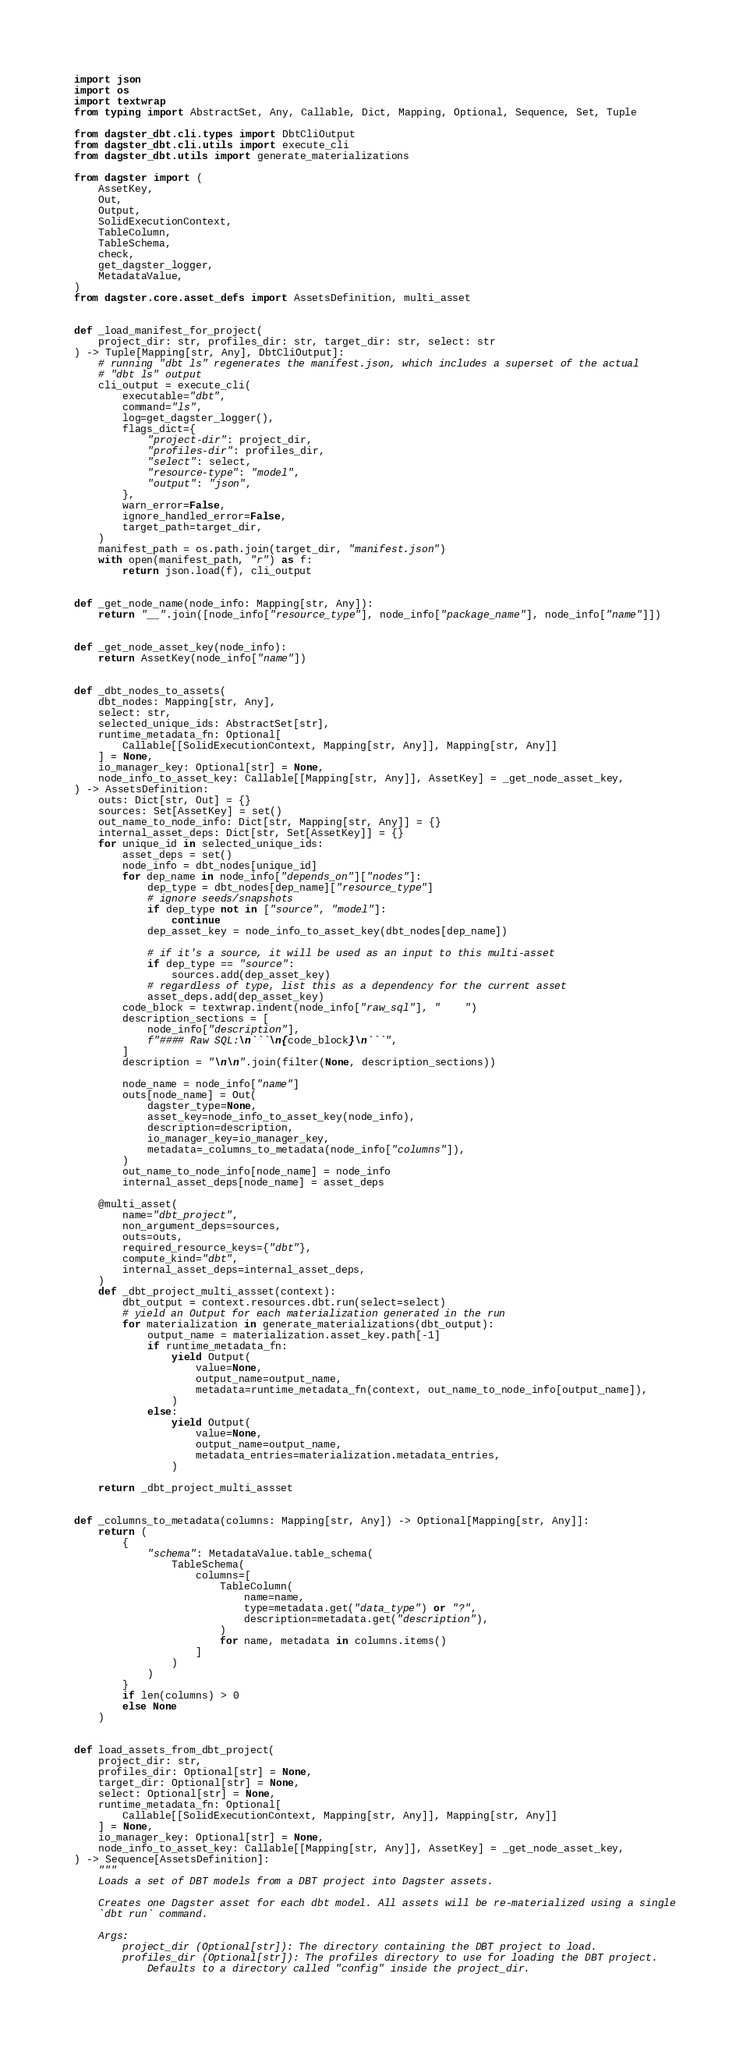Convert code to text. <code><loc_0><loc_0><loc_500><loc_500><_Python_>import json
import os
import textwrap
from typing import AbstractSet, Any, Callable, Dict, Mapping, Optional, Sequence, Set, Tuple

from dagster_dbt.cli.types import DbtCliOutput
from dagster_dbt.cli.utils import execute_cli
from dagster_dbt.utils import generate_materializations

from dagster import (
    AssetKey,
    Out,
    Output,
    SolidExecutionContext,
    TableColumn,
    TableSchema,
    check,
    get_dagster_logger,
    MetadataValue,
)
from dagster.core.asset_defs import AssetsDefinition, multi_asset


def _load_manifest_for_project(
    project_dir: str, profiles_dir: str, target_dir: str, select: str
) -> Tuple[Mapping[str, Any], DbtCliOutput]:
    # running "dbt ls" regenerates the manifest.json, which includes a superset of the actual
    # "dbt ls" output
    cli_output = execute_cli(
        executable="dbt",
        command="ls",
        log=get_dagster_logger(),
        flags_dict={
            "project-dir": project_dir,
            "profiles-dir": profiles_dir,
            "select": select,
            "resource-type": "model",
            "output": "json",
        },
        warn_error=False,
        ignore_handled_error=False,
        target_path=target_dir,
    )
    manifest_path = os.path.join(target_dir, "manifest.json")
    with open(manifest_path, "r") as f:
        return json.load(f), cli_output


def _get_node_name(node_info: Mapping[str, Any]):
    return "__".join([node_info["resource_type"], node_info["package_name"], node_info["name"]])


def _get_node_asset_key(node_info):
    return AssetKey(node_info["name"])


def _dbt_nodes_to_assets(
    dbt_nodes: Mapping[str, Any],
    select: str,
    selected_unique_ids: AbstractSet[str],
    runtime_metadata_fn: Optional[
        Callable[[SolidExecutionContext, Mapping[str, Any]], Mapping[str, Any]]
    ] = None,
    io_manager_key: Optional[str] = None,
    node_info_to_asset_key: Callable[[Mapping[str, Any]], AssetKey] = _get_node_asset_key,
) -> AssetsDefinition:
    outs: Dict[str, Out] = {}
    sources: Set[AssetKey] = set()
    out_name_to_node_info: Dict[str, Mapping[str, Any]] = {}
    internal_asset_deps: Dict[str, Set[AssetKey]] = {}
    for unique_id in selected_unique_ids:
        asset_deps = set()
        node_info = dbt_nodes[unique_id]
        for dep_name in node_info["depends_on"]["nodes"]:
            dep_type = dbt_nodes[dep_name]["resource_type"]
            # ignore seeds/snapshots
            if dep_type not in ["source", "model"]:
                continue
            dep_asset_key = node_info_to_asset_key(dbt_nodes[dep_name])

            # if it's a source, it will be used as an input to this multi-asset
            if dep_type == "source":
                sources.add(dep_asset_key)
            # regardless of type, list this as a dependency for the current asset
            asset_deps.add(dep_asset_key)
        code_block = textwrap.indent(node_info["raw_sql"], "    ")
        description_sections = [
            node_info["description"],
            f"#### Raw SQL:\n```\n{code_block}\n```",
        ]
        description = "\n\n".join(filter(None, description_sections))

        node_name = node_info["name"]
        outs[node_name] = Out(
            dagster_type=None,
            asset_key=node_info_to_asset_key(node_info),
            description=description,
            io_manager_key=io_manager_key,
            metadata=_columns_to_metadata(node_info["columns"]),
        )
        out_name_to_node_info[node_name] = node_info
        internal_asset_deps[node_name] = asset_deps

    @multi_asset(
        name="dbt_project",
        non_argument_deps=sources,
        outs=outs,
        required_resource_keys={"dbt"},
        compute_kind="dbt",
        internal_asset_deps=internal_asset_deps,
    )
    def _dbt_project_multi_assset(context):
        dbt_output = context.resources.dbt.run(select=select)
        # yield an Output for each materialization generated in the run
        for materialization in generate_materializations(dbt_output):
            output_name = materialization.asset_key.path[-1]
            if runtime_metadata_fn:
                yield Output(
                    value=None,
                    output_name=output_name,
                    metadata=runtime_metadata_fn(context, out_name_to_node_info[output_name]),
                )
            else:
                yield Output(
                    value=None,
                    output_name=output_name,
                    metadata_entries=materialization.metadata_entries,
                )

    return _dbt_project_multi_assset


def _columns_to_metadata(columns: Mapping[str, Any]) -> Optional[Mapping[str, Any]]:
    return (
        {
            "schema": MetadataValue.table_schema(
                TableSchema(
                    columns=[
                        TableColumn(
                            name=name,
                            type=metadata.get("data_type") or "?",
                            description=metadata.get("description"),
                        )
                        for name, metadata in columns.items()
                    ]
                )
            )
        }
        if len(columns) > 0
        else None
    )


def load_assets_from_dbt_project(
    project_dir: str,
    profiles_dir: Optional[str] = None,
    target_dir: Optional[str] = None,
    select: Optional[str] = None,
    runtime_metadata_fn: Optional[
        Callable[[SolidExecutionContext, Mapping[str, Any]], Mapping[str, Any]]
    ] = None,
    io_manager_key: Optional[str] = None,
    node_info_to_asset_key: Callable[[Mapping[str, Any]], AssetKey] = _get_node_asset_key,
) -> Sequence[AssetsDefinition]:
    """
    Loads a set of DBT models from a DBT project into Dagster assets.

    Creates one Dagster asset for each dbt model. All assets will be re-materialized using a single
    `dbt run` command.

    Args:
        project_dir (Optional[str]): The directory containing the DBT project to load.
        profiles_dir (Optional[str]): The profiles directory to use for loading the DBT project.
            Defaults to a directory called "config" inside the project_dir.</code> 